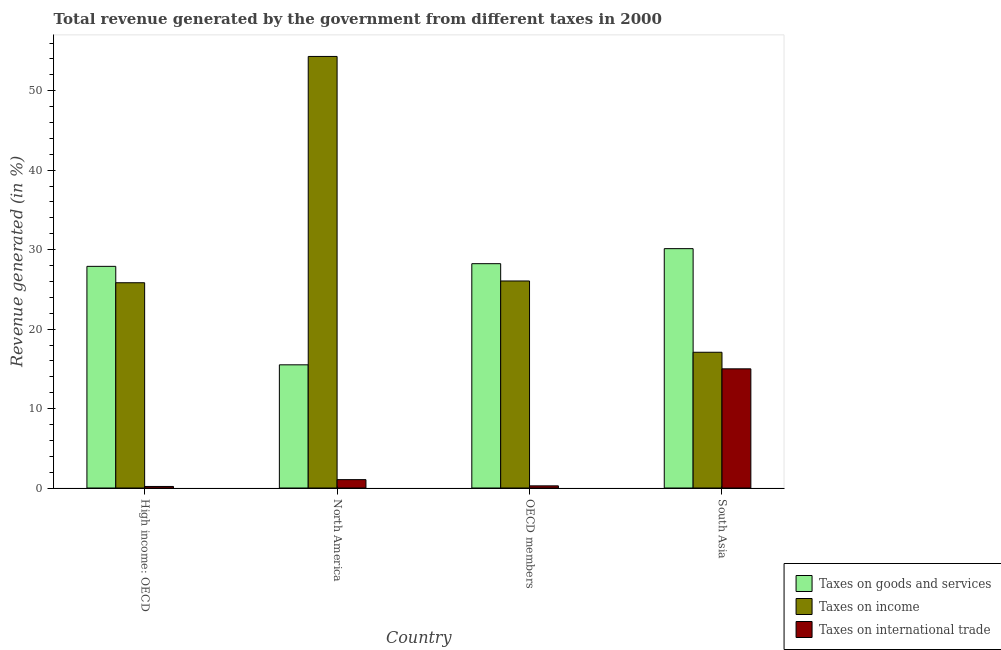How many groups of bars are there?
Keep it short and to the point. 4. How many bars are there on the 3rd tick from the left?
Ensure brevity in your answer.  3. How many bars are there on the 2nd tick from the right?
Provide a short and direct response. 3. What is the percentage of revenue generated by tax on international trade in High income: OECD?
Give a very brief answer. 0.19. Across all countries, what is the maximum percentage of revenue generated by tax on international trade?
Keep it short and to the point. 15. Across all countries, what is the minimum percentage of revenue generated by taxes on goods and services?
Your answer should be very brief. 15.51. In which country was the percentage of revenue generated by taxes on income minimum?
Offer a very short reply. South Asia. What is the total percentage of revenue generated by taxes on income in the graph?
Your answer should be compact. 123.3. What is the difference between the percentage of revenue generated by tax on international trade in North America and that in South Asia?
Offer a very short reply. -13.95. What is the difference between the percentage of revenue generated by tax on international trade in High income: OECD and the percentage of revenue generated by taxes on goods and services in OECD members?
Offer a very short reply. -28.04. What is the average percentage of revenue generated by tax on international trade per country?
Keep it short and to the point. 4.13. What is the difference between the percentage of revenue generated by taxes on income and percentage of revenue generated by tax on international trade in North America?
Keep it short and to the point. 53.27. What is the ratio of the percentage of revenue generated by taxes on income in North America to that in OECD members?
Your response must be concise. 2.08. What is the difference between the highest and the second highest percentage of revenue generated by taxes on goods and services?
Offer a very short reply. 1.89. What is the difference between the highest and the lowest percentage of revenue generated by taxes on goods and services?
Make the answer very short. 14.62. What does the 1st bar from the left in OECD members represents?
Give a very brief answer. Taxes on goods and services. What does the 1st bar from the right in South Asia represents?
Provide a short and direct response. Taxes on international trade. Is it the case that in every country, the sum of the percentage of revenue generated by taxes on goods and services and percentage of revenue generated by taxes on income is greater than the percentage of revenue generated by tax on international trade?
Your answer should be compact. Yes. How many bars are there?
Offer a terse response. 12. Are all the bars in the graph horizontal?
Your response must be concise. No. What is the difference between two consecutive major ticks on the Y-axis?
Your answer should be very brief. 10. Are the values on the major ticks of Y-axis written in scientific E-notation?
Provide a short and direct response. No. How many legend labels are there?
Provide a short and direct response. 3. What is the title of the graph?
Your answer should be very brief. Total revenue generated by the government from different taxes in 2000. What is the label or title of the X-axis?
Your answer should be very brief. Country. What is the label or title of the Y-axis?
Ensure brevity in your answer.  Revenue generated (in %). What is the Revenue generated (in %) in Taxes on goods and services in High income: OECD?
Ensure brevity in your answer.  27.9. What is the Revenue generated (in %) in Taxes on income in High income: OECD?
Give a very brief answer. 25.84. What is the Revenue generated (in %) of Taxes on international trade in High income: OECD?
Your answer should be compact. 0.19. What is the Revenue generated (in %) of Taxes on goods and services in North America?
Offer a terse response. 15.51. What is the Revenue generated (in %) of Taxes on income in North America?
Keep it short and to the point. 54.32. What is the Revenue generated (in %) in Taxes on international trade in North America?
Keep it short and to the point. 1.05. What is the Revenue generated (in %) of Taxes on goods and services in OECD members?
Make the answer very short. 28.24. What is the Revenue generated (in %) of Taxes on income in OECD members?
Provide a short and direct response. 26.06. What is the Revenue generated (in %) of Taxes on international trade in OECD members?
Keep it short and to the point. 0.27. What is the Revenue generated (in %) of Taxes on goods and services in South Asia?
Offer a very short reply. 30.13. What is the Revenue generated (in %) of Taxes on income in South Asia?
Make the answer very short. 17.09. What is the Revenue generated (in %) in Taxes on international trade in South Asia?
Provide a short and direct response. 15. Across all countries, what is the maximum Revenue generated (in %) in Taxes on goods and services?
Offer a very short reply. 30.13. Across all countries, what is the maximum Revenue generated (in %) in Taxes on income?
Make the answer very short. 54.32. Across all countries, what is the maximum Revenue generated (in %) in Taxes on international trade?
Make the answer very short. 15. Across all countries, what is the minimum Revenue generated (in %) of Taxes on goods and services?
Ensure brevity in your answer.  15.51. Across all countries, what is the minimum Revenue generated (in %) in Taxes on income?
Offer a very short reply. 17.09. Across all countries, what is the minimum Revenue generated (in %) of Taxes on international trade?
Keep it short and to the point. 0.19. What is the total Revenue generated (in %) of Taxes on goods and services in the graph?
Your response must be concise. 101.77. What is the total Revenue generated (in %) of Taxes on income in the graph?
Give a very brief answer. 123.3. What is the total Revenue generated (in %) of Taxes on international trade in the graph?
Keep it short and to the point. 16.52. What is the difference between the Revenue generated (in %) of Taxes on goods and services in High income: OECD and that in North America?
Provide a succinct answer. 12.39. What is the difference between the Revenue generated (in %) of Taxes on income in High income: OECD and that in North America?
Your answer should be very brief. -28.48. What is the difference between the Revenue generated (in %) in Taxes on international trade in High income: OECD and that in North America?
Provide a succinct answer. -0.86. What is the difference between the Revenue generated (in %) of Taxes on goods and services in High income: OECD and that in OECD members?
Offer a terse response. -0.34. What is the difference between the Revenue generated (in %) of Taxes on income in High income: OECD and that in OECD members?
Your answer should be very brief. -0.22. What is the difference between the Revenue generated (in %) of Taxes on international trade in High income: OECD and that in OECD members?
Give a very brief answer. -0.08. What is the difference between the Revenue generated (in %) in Taxes on goods and services in High income: OECD and that in South Asia?
Offer a terse response. -2.23. What is the difference between the Revenue generated (in %) of Taxes on income in High income: OECD and that in South Asia?
Ensure brevity in your answer.  8.75. What is the difference between the Revenue generated (in %) in Taxes on international trade in High income: OECD and that in South Asia?
Offer a very short reply. -14.81. What is the difference between the Revenue generated (in %) in Taxes on goods and services in North America and that in OECD members?
Provide a short and direct response. -12.73. What is the difference between the Revenue generated (in %) of Taxes on income in North America and that in OECD members?
Offer a very short reply. 28.26. What is the difference between the Revenue generated (in %) in Taxes on international trade in North America and that in OECD members?
Provide a short and direct response. 0.78. What is the difference between the Revenue generated (in %) of Taxes on goods and services in North America and that in South Asia?
Give a very brief answer. -14.62. What is the difference between the Revenue generated (in %) in Taxes on income in North America and that in South Asia?
Offer a very short reply. 37.23. What is the difference between the Revenue generated (in %) in Taxes on international trade in North America and that in South Asia?
Your response must be concise. -13.95. What is the difference between the Revenue generated (in %) in Taxes on goods and services in OECD members and that in South Asia?
Ensure brevity in your answer.  -1.89. What is the difference between the Revenue generated (in %) of Taxes on income in OECD members and that in South Asia?
Offer a very short reply. 8.97. What is the difference between the Revenue generated (in %) in Taxes on international trade in OECD members and that in South Asia?
Provide a succinct answer. -14.73. What is the difference between the Revenue generated (in %) of Taxes on goods and services in High income: OECD and the Revenue generated (in %) of Taxes on income in North America?
Provide a succinct answer. -26.42. What is the difference between the Revenue generated (in %) in Taxes on goods and services in High income: OECD and the Revenue generated (in %) in Taxes on international trade in North America?
Provide a short and direct response. 26.84. What is the difference between the Revenue generated (in %) in Taxes on income in High income: OECD and the Revenue generated (in %) in Taxes on international trade in North America?
Keep it short and to the point. 24.78. What is the difference between the Revenue generated (in %) of Taxes on goods and services in High income: OECD and the Revenue generated (in %) of Taxes on income in OECD members?
Ensure brevity in your answer.  1.84. What is the difference between the Revenue generated (in %) of Taxes on goods and services in High income: OECD and the Revenue generated (in %) of Taxes on international trade in OECD members?
Offer a very short reply. 27.63. What is the difference between the Revenue generated (in %) of Taxes on income in High income: OECD and the Revenue generated (in %) of Taxes on international trade in OECD members?
Ensure brevity in your answer.  25.57. What is the difference between the Revenue generated (in %) of Taxes on goods and services in High income: OECD and the Revenue generated (in %) of Taxes on income in South Asia?
Your response must be concise. 10.81. What is the difference between the Revenue generated (in %) in Taxes on goods and services in High income: OECD and the Revenue generated (in %) in Taxes on international trade in South Asia?
Your answer should be very brief. 12.9. What is the difference between the Revenue generated (in %) of Taxes on income in High income: OECD and the Revenue generated (in %) of Taxes on international trade in South Asia?
Ensure brevity in your answer.  10.84. What is the difference between the Revenue generated (in %) in Taxes on goods and services in North America and the Revenue generated (in %) in Taxes on income in OECD members?
Provide a short and direct response. -10.55. What is the difference between the Revenue generated (in %) of Taxes on goods and services in North America and the Revenue generated (in %) of Taxes on international trade in OECD members?
Your response must be concise. 15.24. What is the difference between the Revenue generated (in %) in Taxes on income in North America and the Revenue generated (in %) in Taxes on international trade in OECD members?
Give a very brief answer. 54.05. What is the difference between the Revenue generated (in %) of Taxes on goods and services in North America and the Revenue generated (in %) of Taxes on income in South Asia?
Your answer should be very brief. -1.58. What is the difference between the Revenue generated (in %) in Taxes on goods and services in North America and the Revenue generated (in %) in Taxes on international trade in South Asia?
Give a very brief answer. 0.51. What is the difference between the Revenue generated (in %) in Taxes on income in North America and the Revenue generated (in %) in Taxes on international trade in South Asia?
Offer a terse response. 39.32. What is the difference between the Revenue generated (in %) in Taxes on goods and services in OECD members and the Revenue generated (in %) in Taxes on income in South Asia?
Offer a very short reply. 11.15. What is the difference between the Revenue generated (in %) in Taxes on goods and services in OECD members and the Revenue generated (in %) in Taxes on international trade in South Asia?
Offer a terse response. 13.24. What is the difference between the Revenue generated (in %) of Taxes on income in OECD members and the Revenue generated (in %) of Taxes on international trade in South Asia?
Offer a terse response. 11.06. What is the average Revenue generated (in %) in Taxes on goods and services per country?
Keep it short and to the point. 25.44. What is the average Revenue generated (in %) in Taxes on income per country?
Your response must be concise. 30.83. What is the average Revenue generated (in %) of Taxes on international trade per country?
Your answer should be compact. 4.13. What is the difference between the Revenue generated (in %) in Taxes on goods and services and Revenue generated (in %) in Taxes on income in High income: OECD?
Your answer should be compact. 2.06. What is the difference between the Revenue generated (in %) in Taxes on goods and services and Revenue generated (in %) in Taxes on international trade in High income: OECD?
Your response must be concise. 27.7. What is the difference between the Revenue generated (in %) of Taxes on income and Revenue generated (in %) of Taxes on international trade in High income: OECD?
Offer a very short reply. 25.64. What is the difference between the Revenue generated (in %) in Taxes on goods and services and Revenue generated (in %) in Taxes on income in North America?
Provide a short and direct response. -38.81. What is the difference between the Revenue generated (in %) of Taxes on goods and services and Revenue generated (in %) of Taxes on international trade in North America?
Ensure brevity in your answer.  14.45. What is the difference between the Revenue generated (in %) of Taxes on income and Revenue generated (in %) of Taxes on international trade in North America?
Offer a terse response. 53.27. What is the difference between the Revenue generated (in %) of Taxes on goods and services and Revenue generated (in %) of Taxes on income in OECD members?
Your answer should be compact. 2.18. What is the difference between the Revenue generated (in %) of Taxes on goods and services and Revenue generated (in %) of Taxes on international trade in OECD members?
Your response must be concise. 27.97. What is the difference between the Revenue generated (in %) in Taxes on income and Revenue generated (in %) in Taxes on international trade in OECD members?
Your answer should be very brief. 25.79. What is the difference between the Revenue generated (in %) in Taxes on goods and services and Revenue generated (in %) in Taxes on income in South Asia?
Provide a succinct answer. 13.04. What is the difference between the Revenue generated (in %) of Taxes on goods and services and Revenue generated (in %) of Taxes on international trade in South Asia?
Your answer should be very brief. 15.13. What is the difference between the Revenue generated (in %) of Taxes on income and Revenue generated (in %) of Taxes on international trade in South Asia?
Keep it short and to the point. 2.09. What is the ratio of the Revenue generated (in %) in Taxes on goods and services in High income: OECD to that in North America?
Ensure brevity in your answer.  1.8. What is the ratio of the Revenue generated (in %) in Taxes on income in High income: OECD to that in North America?
Your answer should be compact. 0.48. What is the ratio of the Revenue generated (in %) in Taxes on international trade in High income: OECD to that in North America?
Your response must be concise. 0.18. What is the ratio of the Revenue generated (in %) of Taxes on goods and services in High income: OECD to that in OECD members?
Your answer should be very brief. 0.99. What is the ratio of the Revenue generated (in %) in Taxes on income in High income: OECD to that in OECD members?
Provide a succinct answer. 0.99. What is the ratio of the Revenue generated (in %) in Taxes on international trade in High income: OECD to that in OECD members?
Your response must be concise. 0.72. What is the ratio of the Revenue generated (in %) of Taxes on goods and services in High income: OECD to that in South Asia?
Your answer should be very brief. 0.93. What is the ratio of the Revenue generated (in %) of Taxes on income in High income: OECD to that in South Asia?
Ensure brevity in your answer.  1.51. What is the ratio of the Revenue generated (in %) of Taxes on international trade in High income: OECD to that in South Asia?
Give a very brief answer. 0.01. What is the ratio of the Revenue generated (in %) of Taxes on goods and services in North America to that in OECD members?
Make the answer very short. 0.55. What is the ratio of the Revenue generated (in %) in Taxes on income in North America to that in OECD members?
Your answer should be very brief. 2.08. What is the ratio of the Revenue generated (in %) of Taxes on international trade in North America to that in OECD members?
Offer a terse response. 3.9. What is the ratio of the Revenue generated (in %) in Taxes on goods and services in North America to that in South Asia?
Your answer should be compact. 0.51. What is the ratio of the Revenue generated (in %) in Taxes on income in North America to that in South Asia?
Offer a terse response. 3.18. What is the ratio of the Revenue generated (in %) of Taxes on international trade in North America to that in South Asia?
Offer a very short reply. 0.07. What is the ratio of the Revenue generated (in %) of Taxes on goods and services in OECD members to that in South Asia?
Give a very brief answer. 0.94. What is the ratio of the Revenue generated (in %) of Taxes on income in OECD members to that in South Asia?
Offer a terse response. 1.53. What is the ratio of the Revenue generated (in %) in Taxes on international trade in OECD members to that in South Asia?
Your answer should be very brief. 0.02. What is the difference between the highest and the second highest Revenue generated (in %) in Taxes on goods and services?
Keep it short and to the point. 1.89. What is the difference between the highest and the second highest Revenue generated (in %) of Taxes on income?
Give a very brief answer. 28.26. What is the difference between the highest and the second highest Revenue generated (in %) in Taxes on international trade?
Make the answer very short. 13.95. What is the difference between the highest and the lowest Revenue generated (in %) of Taxes on goods and services?
Offer a terse response. 14.62. What is the difference between the highest and the lowest Revenue generated (in %) in Taxes on income?
Your response must be concise. 37.23. What is the difference between the highest and the lowest Revenue generated (in %) in Taxes on international trade?
Your answer should be compact. 14.81. 